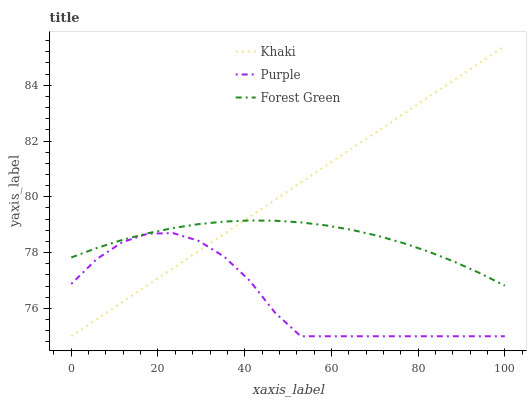Does Purple have the minimum area under the curve?
Answer yes or no. Yes. Does Khaki have the maximum area under the curve?
Answer yes or no. Yes. Does Forest Green have the minimum area under the curve?
Answer yes or no. No. Does Forest Green have the maximum area under the curve?
Answer yes or no. No. Is Khaki the smoothest?
Answer yes or no. Yes. Is Purple the roughest?
Answer yes or no. Yes. Is Forest Green the smoothest?
Answer yes or no. No. Is Forest Green the roughest?
Answer yes or no. No. Does Purple have the lowest value?
Answer yes or no. Yes. Does Forest Green have the lowest value?
Answer yes or no. No. Does Khaki have the highest value?
Answer yes or no. Yes. Does Forest Green have the highest value?
Answer yes or no. No. Is Purple less than Forest Green?
Answer yes or no. Yes. Is Forest Green greater than Purple?
Answer yes or no. Yes. Does Purple intersect Khaki?
Answer yes or no. Yes. Is Purple less than Khaki?
Answer yes or no. No. Is Purple greater than Khaki?
Answer yes or no. No. Does Purple intersect Forest Green?
Answer yes or no. No. 